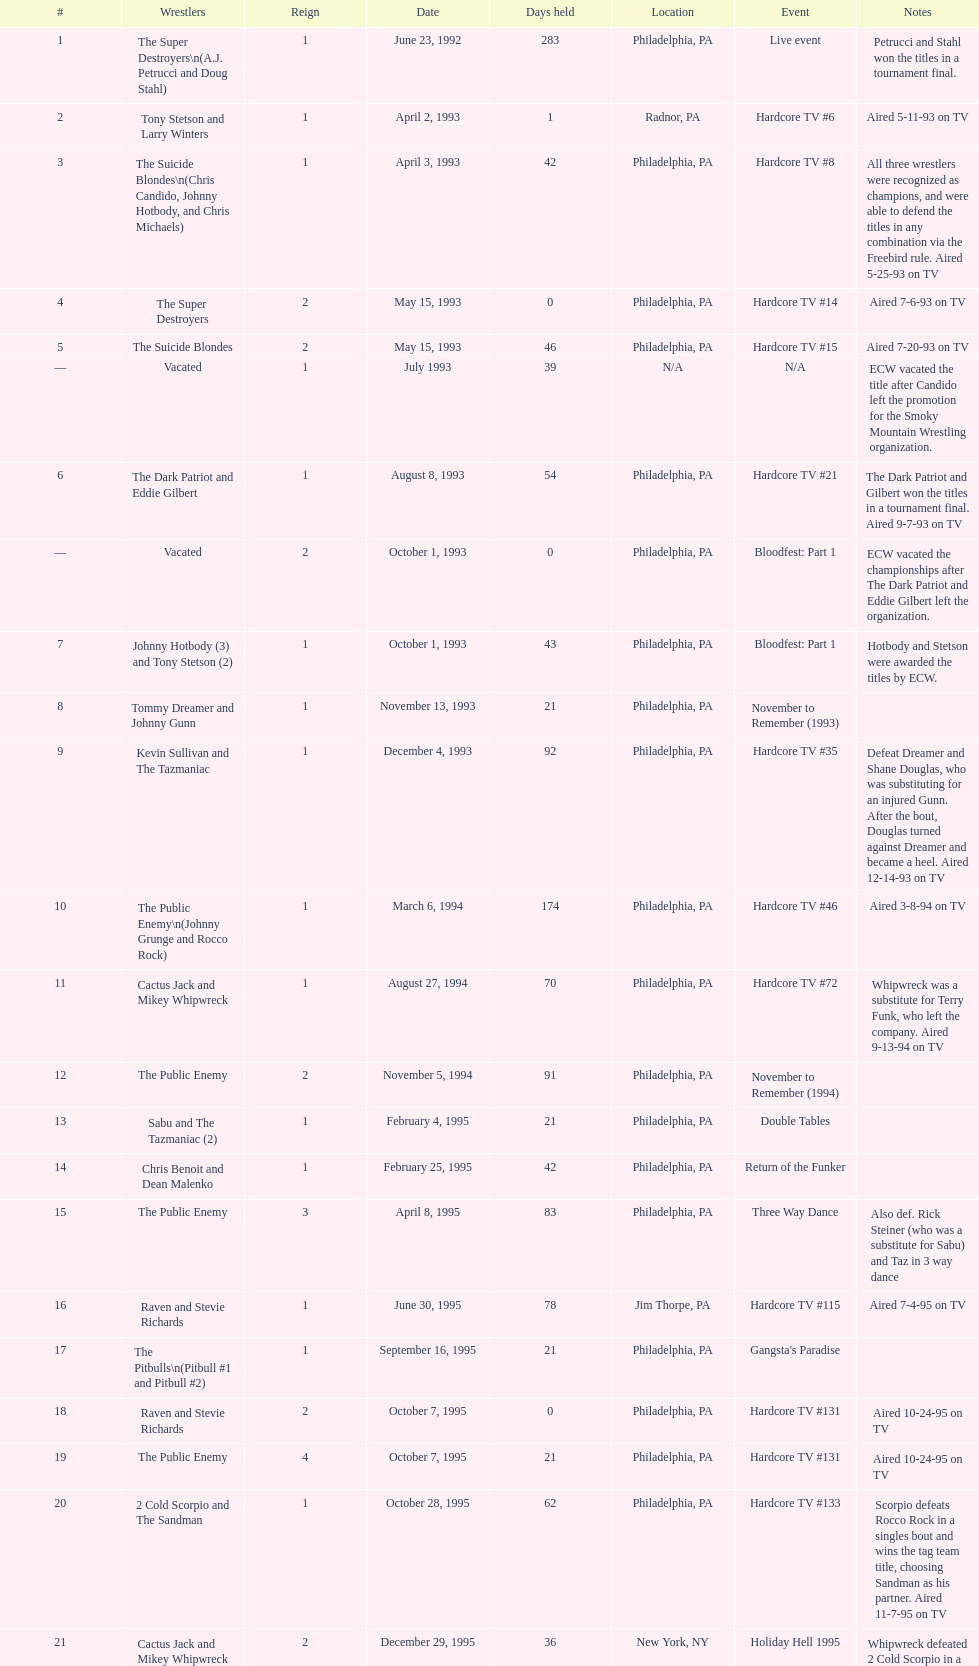What is the total days held on # 1st? 283. 